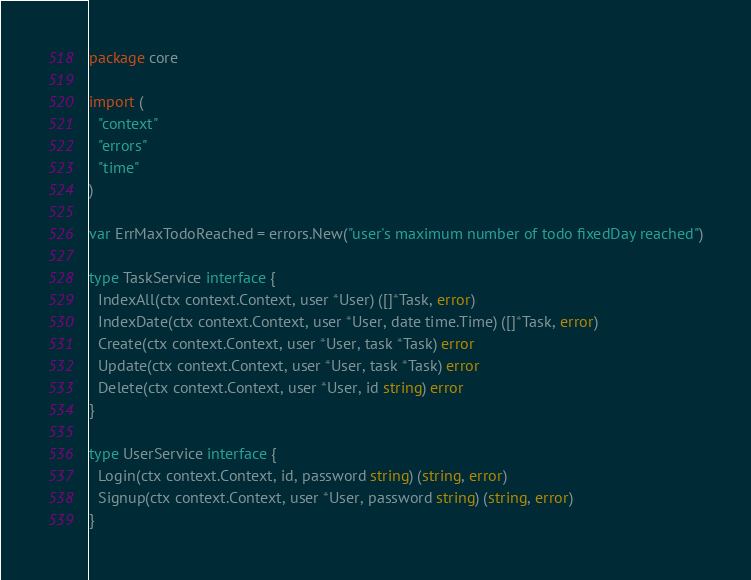<code> <loc_0><loc_0><loc_500><loc_500><_Go_>package core

import (
  "context"
  "errors"
  "time"
)

var ErrMaxTodoReached = errors.New("user's maximum number of todo fixedDay reached")

type TaskService interface {
  IndexAll(ctx context.Context, user *User) ([]*Task, error)
  IndexDate(ctx context.Context, user *User, date time.Time) ([]*Task, error)
  Create(ctx context.Context, user *User, task *Task) error
  Update(ctx context.Context, user *User, task *Task) error
  Delete(ctx context.Context, user *User, id string) error
}

type UserService interface {
  Login(ctx context.Context, id, password string) (string, error)
  Signup(ctx context.Context, user *User, password string) (string, error)
}
</code> 